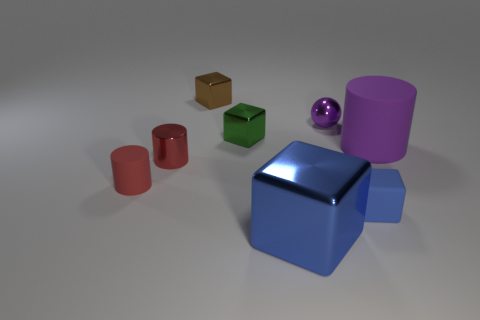Does the large matte cylinder have the same color as the small shiny sphere?
Offer a very short reply. Yes. Are there any other things that have the same color as the metallic cylinder?
Make the answer very short. Yes. There is a tiny rubber object that is in front of the red rubber thing; does it have the same shape as the matte thing that is on the right side of the matte cube?
Provide a succinct answer. No. How many things are yellow cylinders or tiny objects on the right side of the tiny purple sphere?
Ensure brevity in your answer.  1. How many other objects are there of the same size as the green object?
Provide a short and direct response. 5. Is the tiny cube in front of the small red matte cylinder made of the same material as the big object to the left of the small purple metal ball?
Offer a very short reply. No. What number of tiny brown metal blocks are in front of the purple matte cylinder?
Make the answer very short. 0. How many green things are either shiny things or small rubber objects?
Make the answer very short. 1. There is a blue cube that is the same size as the metallic ball; what material is it?
Give a very brief answer. Rubber. The metallic thing that is behind the green object and to the left of the large shiny thing has what shape?
Your answer should be very brief. Cube. 